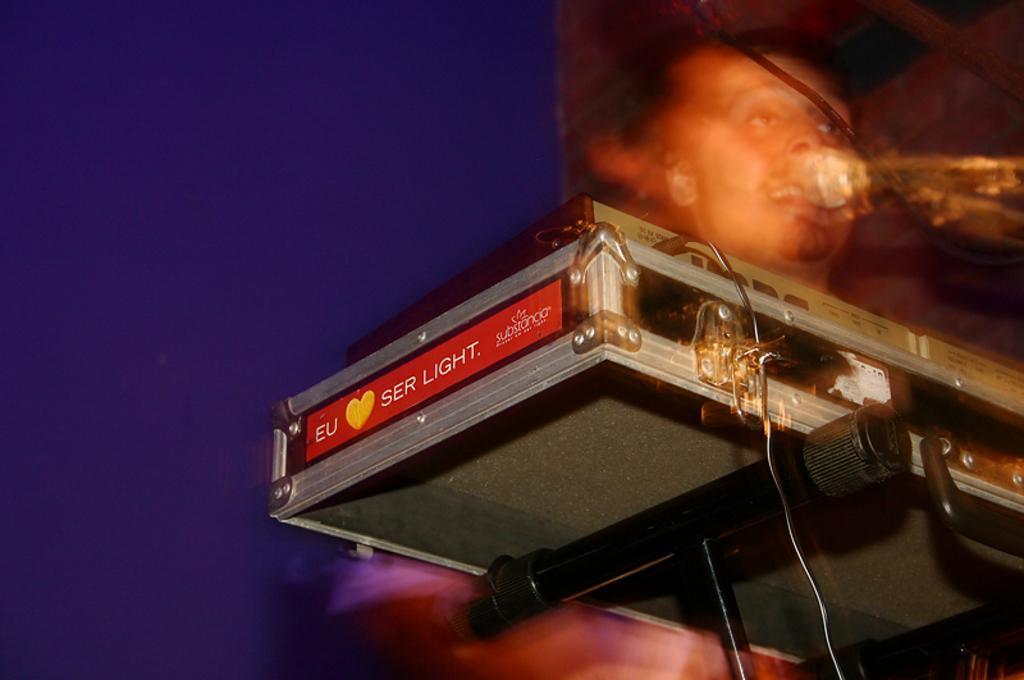In one or two sentences, can you explain what this image depicts? In this picture we can see a device, cable, mic, person and some objects and in the background we can see violet color. 